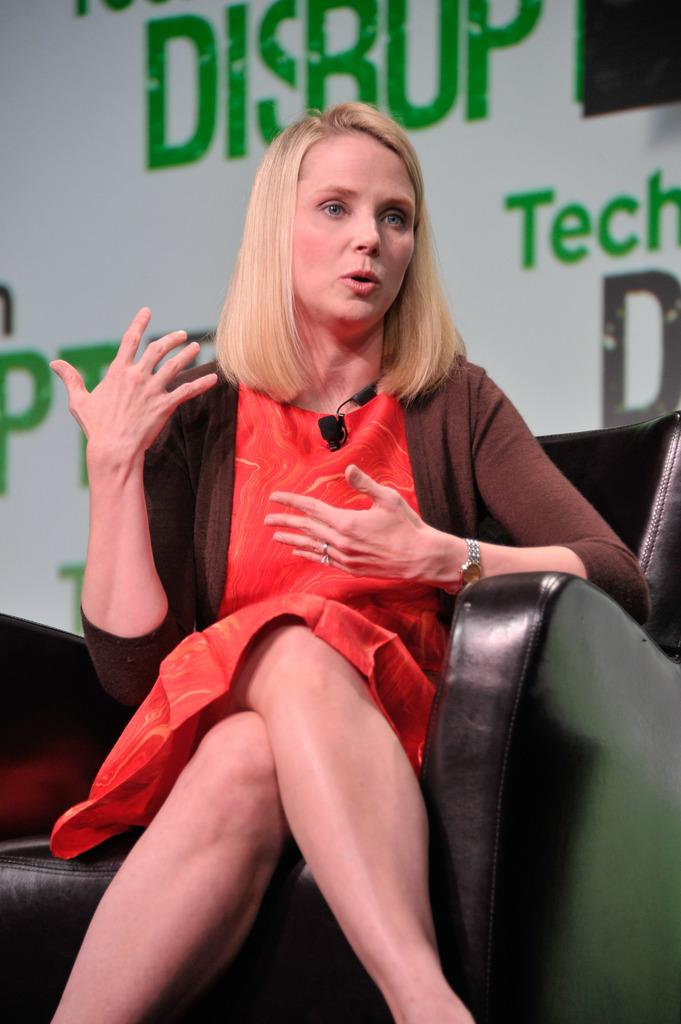Who or what is in the image? There is a person in the image. What is the person doing or where are they located? The person is on a couch. What else can be seen in the image besides the person? There is a wall with text visible in the image. How many apples are on the couch with the person in the image? There is no mention of apples in the image, so it cannot be determined how many apples are present. 